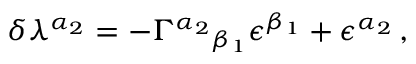Convert formula to latex. <formula><loc_0><loc_0><loc_500><loc_500>\delta \lambda ^ { \alpha _ { 2 } } = - \Gamma ^ { \alpha _ { 2 } _ { \beta _ { 1 } } \epsilon ^ { \beta _ { 1 } } + \epsilon ^ { \alpha _ { 2 } } \, ,</formula> 